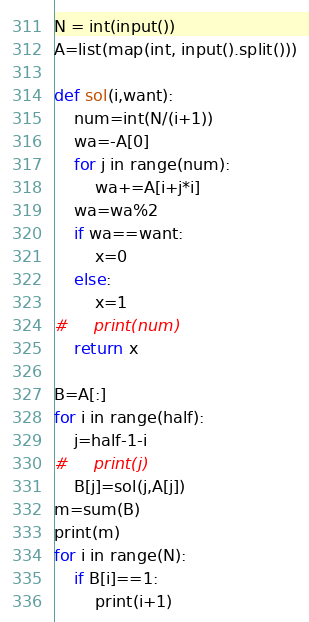<code> <loc_0><loc_0><loc_500><loc_500><_Python_>N = int(input())
A=list(map(int, input().split()))

def sol(i,want):
    num=int(N/(i+1))
    wa=-A[0]
    for j in range(num):
        wa+=A[i+j*i]
    wa=wa%2
    if wa==want:
        x=0
    else:
        x=1
#     print(num)
    return x 

B=A[:]
for i in range(half):
    j=half-1-i
#     print(j)
    B[j]=sol(j,A[j])
m=sum(B)
print(m)
for i in range(N):
    if B[i]==1:
        print(i+1)

</code> 